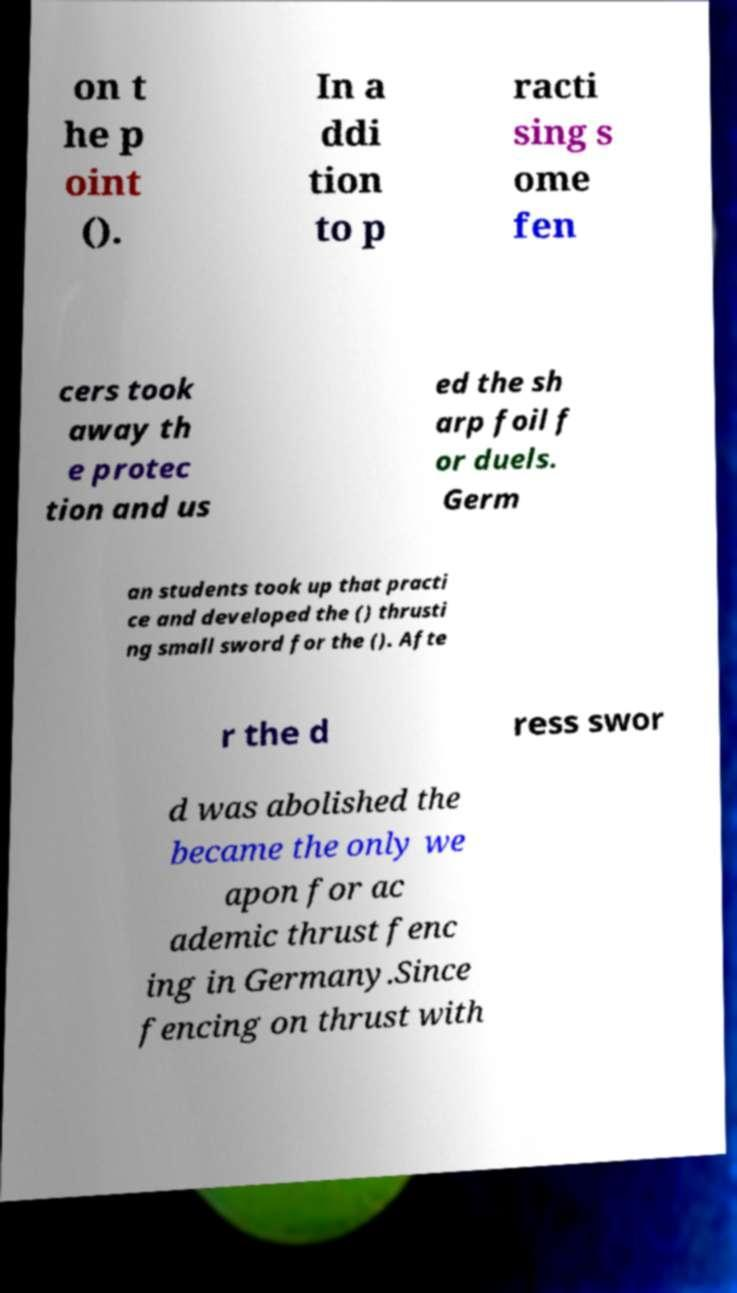There's text embedded in this image that I need extracted. Can you transcribe it verbatim? on t he p oint (). In a ddi tion to p racti sing s ome fen cers took away th e protec tion and us ed the sh arp foil f or duels. Germ an students took up that practi ce and developed the () thrusti ng small sword for the (). Afte r the d ress swor d was abolished the became the only we apon for ac ademic thrust fenc ing in Germany.Since fencing on thrust with 